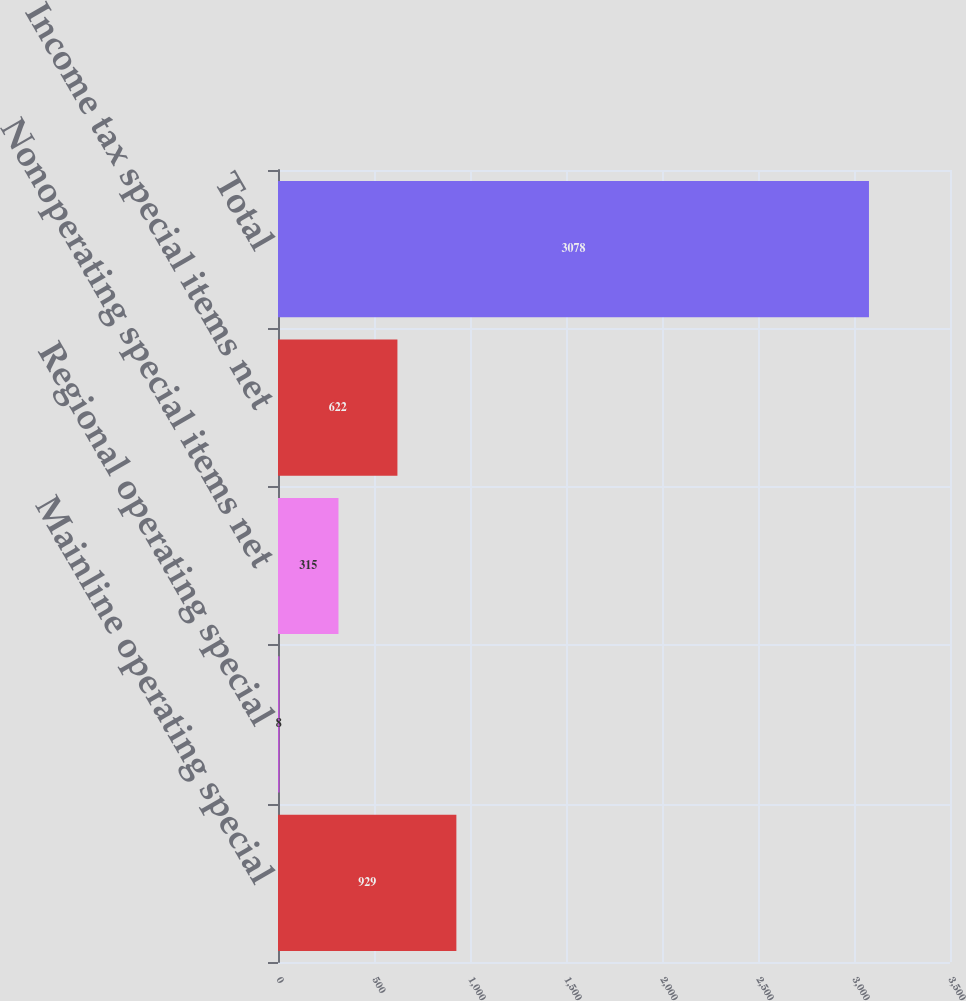Convert chart to OTSL. <chart><loc_0><loc_0><loc_500><loc_500><bar_chart><fcel>Mainline operating special<fcel>Regional operating special<fcel>Nonoperating special items net<fcel>Income tax special items net<fcel>Total<nl><fcel>929<fcel>8<fcel>315<fcel>622<fcel>3078<nl></chart> 